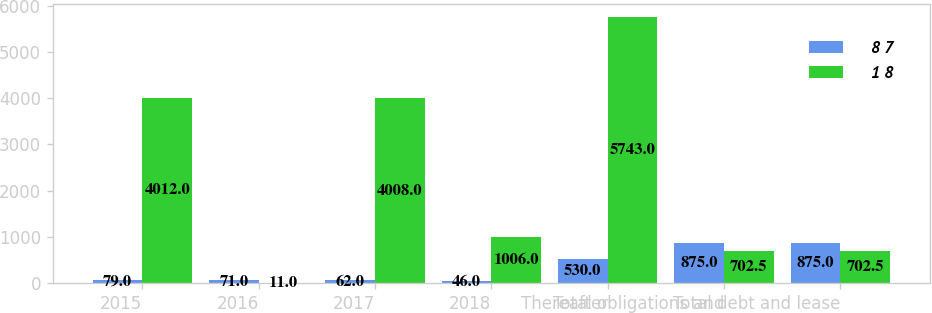Convert chart to OTSL. <chart><loc_0><loc_0><loc_500><loc_500><stacked_bar_chart><ecel><fcel>2015<fcel>2016<fcel>2017<fcel>2018<fcel>Thereafter<fcel>Total obligations and<fcel>Total debt and lease<nl><fcel>8 7<fcel>79<fcel>71<fcel>62<fcel>46<fcel>530<fcel>875<fcel>875<nl><fcel>1 8<fcel>4012<fcel>11<fcel>4008<fcel>1006<fcel>5743<fcel>702.5<fcel>702.5<nl></chart> 